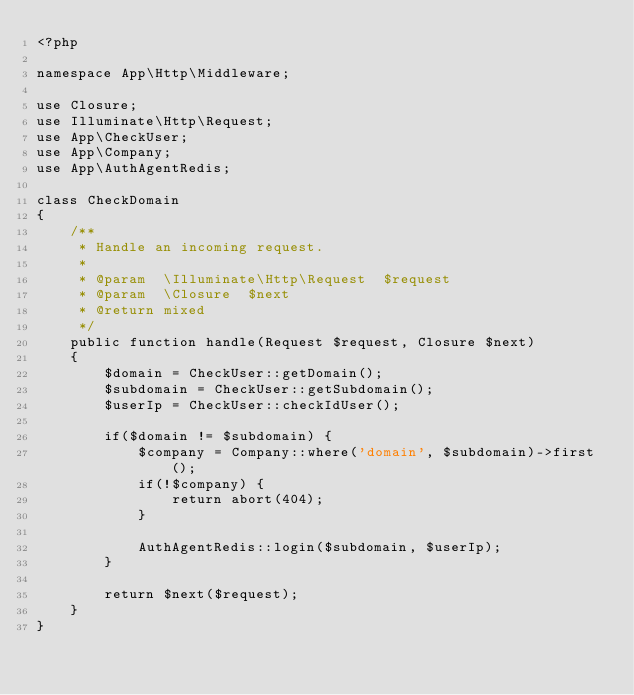<code> <loc_0><loc_0><loc_500><loc_500><_PHP_><?php

namespace App\Http\Middleware;

use Closure;
use Illuminate\Http\Request;
use App\CheckUser;
use App\Company;
use App\AuthAgentRedis;

class CheckDomain
{
    /**
     * Handle an incoming request.
     *
     * @param  \Illuminate\Http\Request  $request
     * @param  \Closure  $next
     * @return mixed
     */
    public function handle(Request $request, Closure $next)
    {
        $domain = CheckUser::getDomain();
        $subdomain = CheckUser::getSubdomain();
        $userIp = CheckUser::checkIdUser();

        if($domain != $subdomain) {
            $company = Company::where('domain', $subdomain)->first();
            if(!$company) {
                return abort(404);
            }

            AuthAgentRedis::login($subdomain, $userIp);
        }

        return $next($request);
    }
}
</code> 